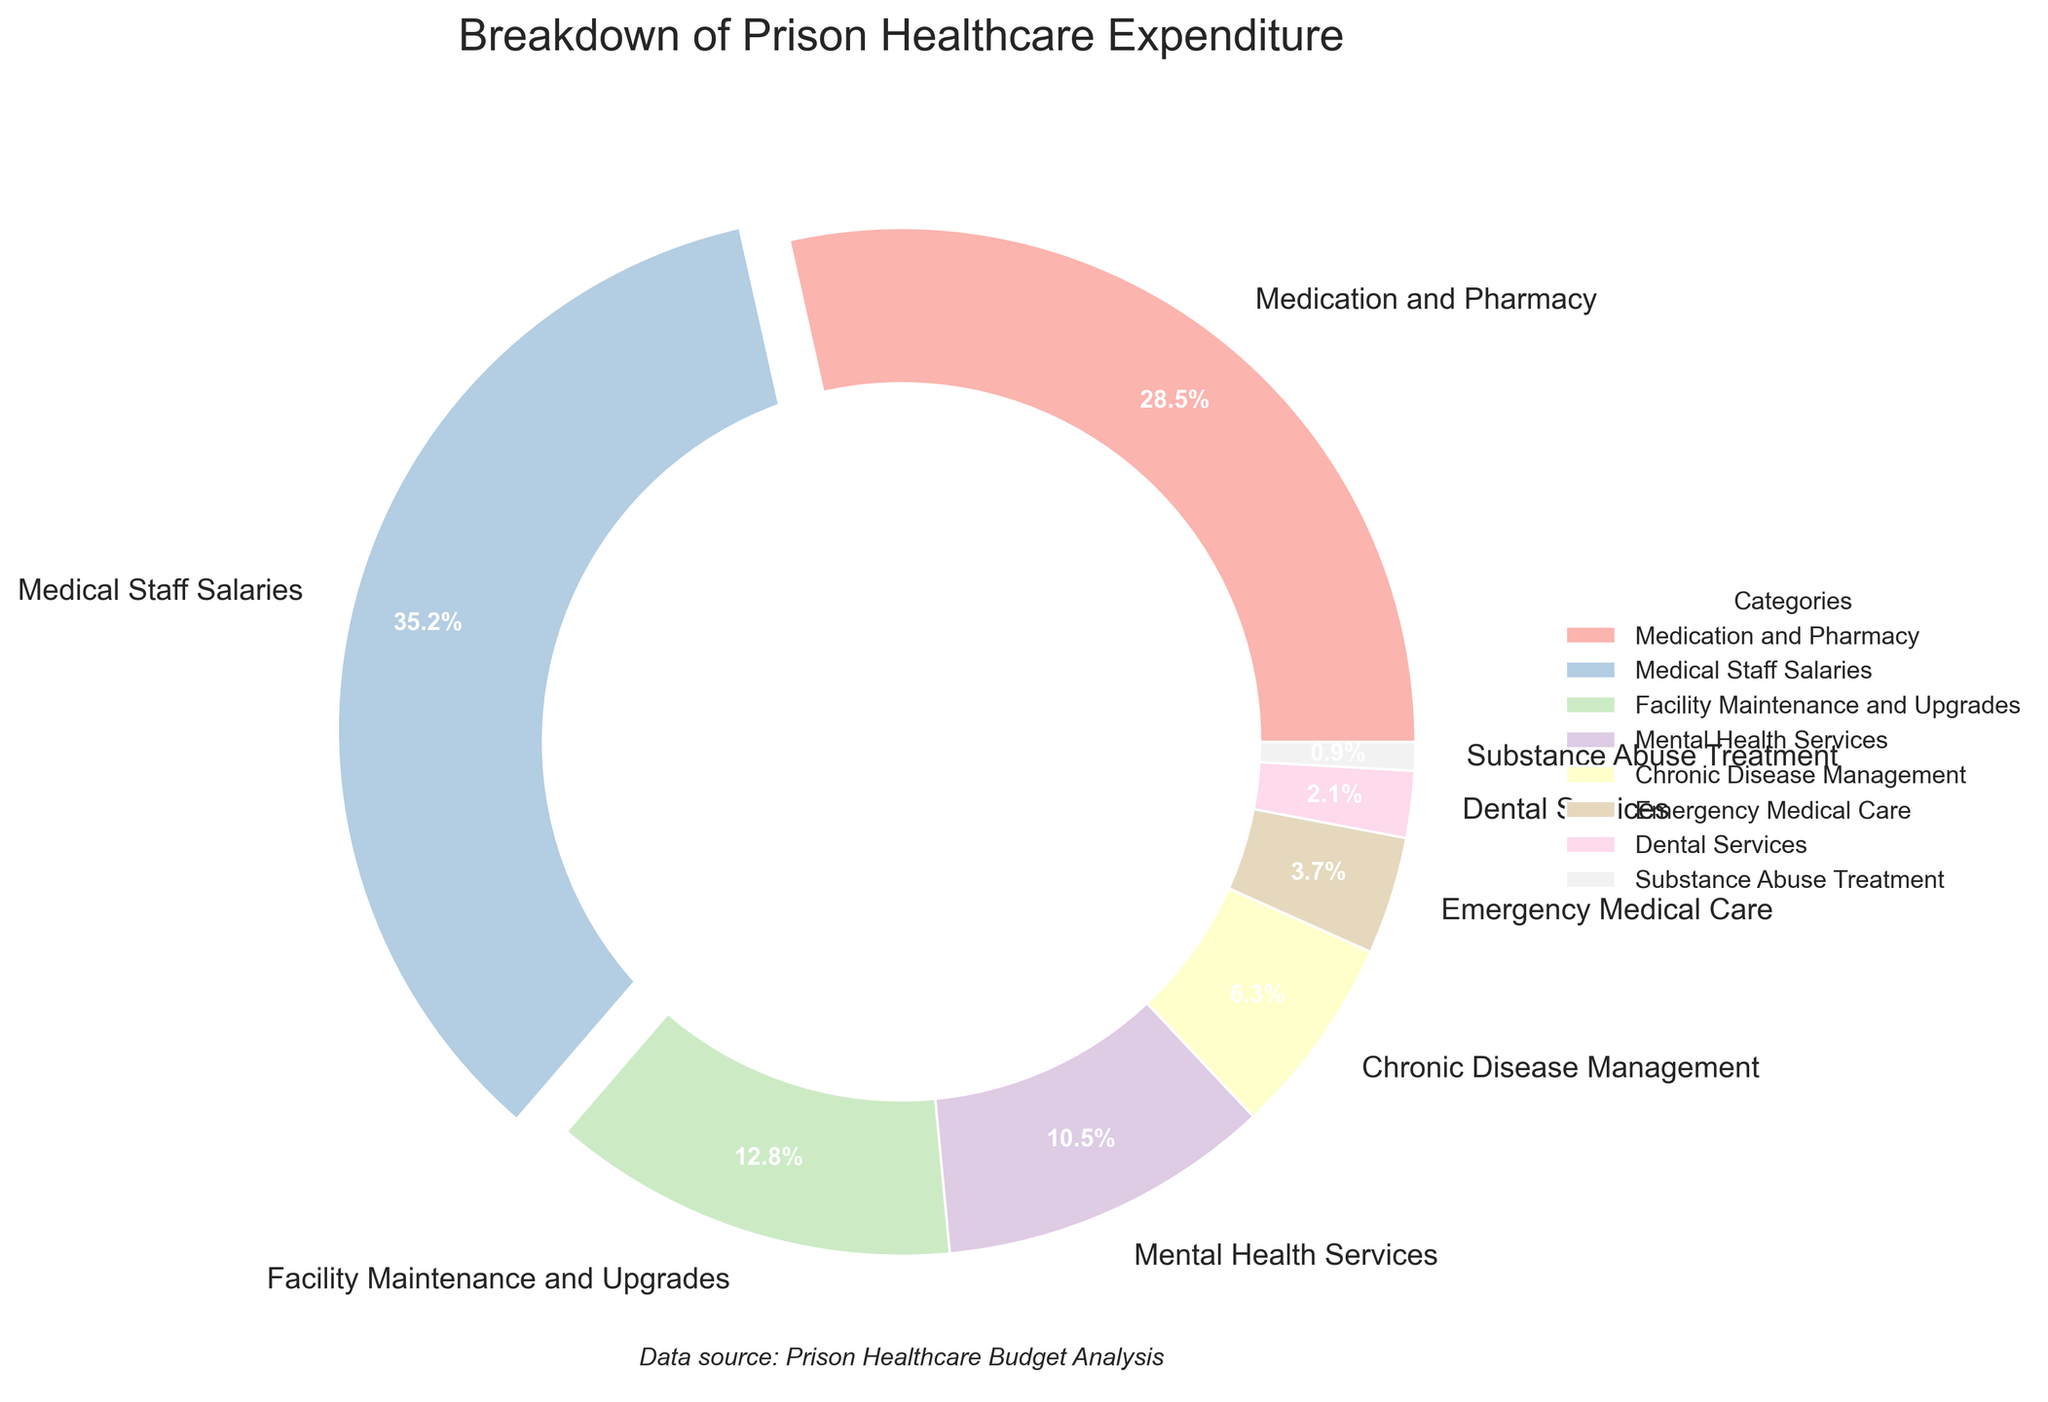Which category has the highest expenditure? By examining the pie chart, the wedge with the largest slice is colored distinctly and has a percentage label indicating 35.2%. This category is "Medical Staff Salaries".
Answer: Medical Staff Salaries What is the combined expenditure percentage for Medication and Pharmacy, and Facility Maintenance and Upgrades? To find the combined expenditure percentage, add the percentages for Medication and Pharmacy (28.5%) and Facility Maintenance and Upgrades (12.8%). The sum is 28.5 + 12.8 = 41.3%.
Answer: 41.3% How does the expenditure on Mental Health Services compare to that on Chronic Disease Management? The pie chart shows that Mental Health Services account for 10.5% of the expenditure, whereas Chronic Disease Management accounts for 6.3%. Therefore, Mental Health Services expenditure is greater.
Answer: Mental Health Services expenditure is greater Which categories combined make up less than 10% of the total expenditure? Identify the categories with percentages less than 10%: Chronic Disease Management (6.3%), Emergency Medical Care (3.7%), Dental Services (2.1%), and Substance Abuse Treatment (0.9%). Combining these gives a total of 6.3 + 3.7 + 2.1 + 0.9 = 13%. The categories to add up to less than 10% are Emergency Medical Care, Dental Services, and Substance Abuse Treatment.
Answer: Emergency Medical Care, Dental Services, and Substance Abuse Treatment What is the approximate difference in expenditure percentages between Medical Staff Salaries and Medication and Pharmacy? Determine the percentages from the chart: Medical Staff Salaries is 35.2% and Medication and Pharmacy is 28.5%. The difference is 35.2 - 28.5 = 6.7%.
Answer: 6.7% Which category has the smallest expenditure, and what is its percentage? The pie chart shows the smallest slice representing the category's expenditure labeled as "Substance Abuse Treatment" with a percentage of 0.9%.
Answer: Substance Abuse Treatment, 0.9% Compare the combined expenditure of Medical Staff Salaries and Medication and Pharmacy to the combined expenditure of all other categories. The combined expenditure of Medical Staff Salaries and Medication and Pharmacy is 35.2% + 28.5% = 63.7%. The combined expenditure for all other categories is 12.8 + 10.5 + 6.3 + 3.7 + 2.1 + 0.9 = 36.3%. Therefore, the first combined expenditure is higher.
Answer: Medical Staff Salaries and Medication and Pharmacy have higher combined expenditure What is the proportion of expenditure on Facility Maintenance and Upgrades compared to Emergency Medical Care? The chart shows Facility Maintenance and Upgrades with 12.8% and Emergency Medical Care with 3.7%. To find the proportion, divide 12.8 by 3.7 which approximately equals 3.46.
Answer: Approximately 3.46 times What percentage of the total expenditure is dedicated to services targeting mental health and chronic diseases combined? Add the percentages for Mental Health Services (10.5%) and Chronic Disease Management (6.3%). The combined expenditure is 10.5 + 6.3 = 16.8%.
Answer: 16.8% What is the approximate ratio of the expenditure on Medical Staff Salaries to the expenditure on Dental Services? From the pie chart, Medical Staff Salaries' expenditure is 35.2% and Dental Services is 2.1%. The ratio is approximately 35.2 / 2.1 which simplifies to 16.76.
Answer: Approximately 17:1 